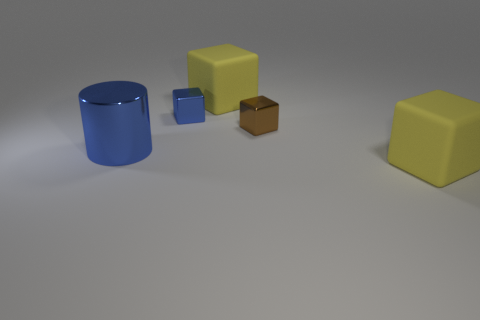What size is the blue shiny object right of the big metallic thing?
Your answer should be very brief. Small. How many large things are either matte things or cylinders?
Your response must be concise. 3. Is there any other thing of the same color as the large shiny cylinder?
Your answer should be very brief. Yes. Are there any blue metal things to the right of the blue metal block?
Offer a terse response. No. How big is the blue object that is on the left side of the blue thing that is on the right side of the big blue metal cylinder?
Provide a short and direct response. Large. Is the number of blue cubes that are to the left of the big shiny cylinder the same as the number of yellow objects that are in front of the blue metallic block?
Keep it short and to the point. No. There is a big yellow object behind the brown block; is there a block behind it?
Your answer should be compact. No. How many small brown objects are on the right side of the large cube to the right of the object that is behind the blue block?
Ensure brevity in your answer.  0. Is the number of big yellow rubber things less than the number of big gray matte spheres?
Ensure brevity in your answer.  No. There is a yellow rubber thing that is in front of the blue cylinder; does it have the same shape as the large object that is behind the cylinder?
Provide a short and direct response. Yes. 